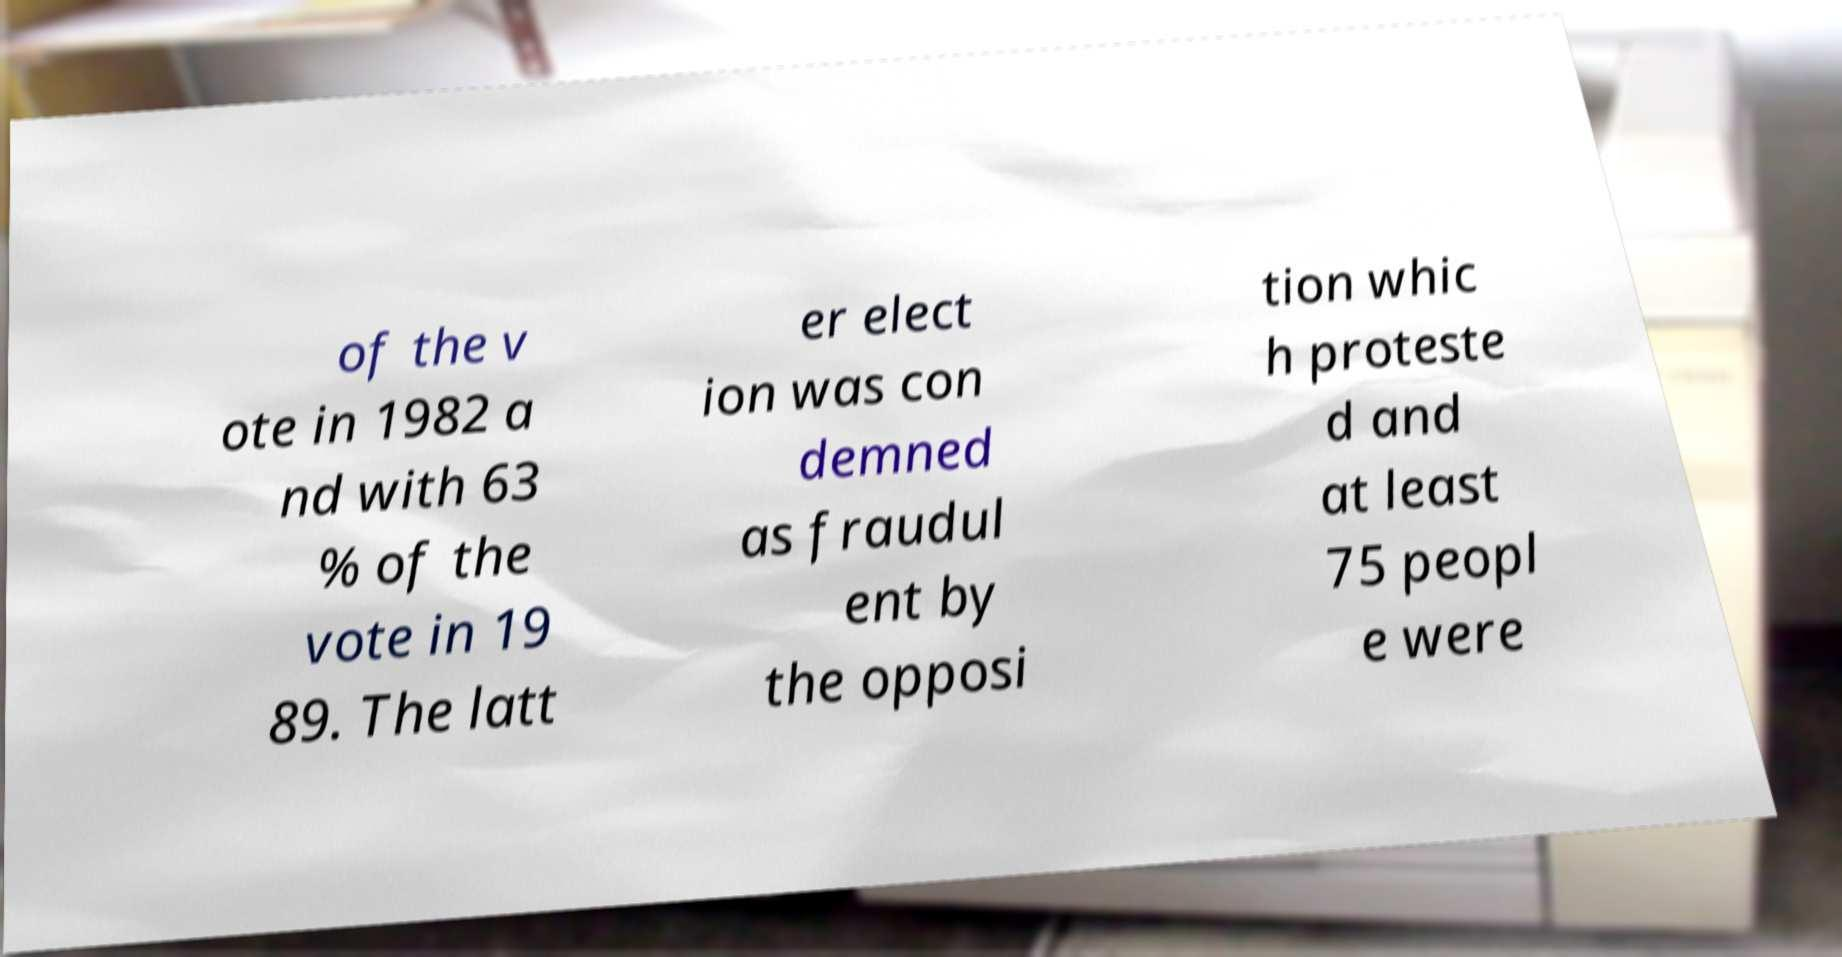There's text embedded in this image that I need extracted. Can you transcribe it verbatim? of the v ote in 1982 a nd with 63 % of the vote in 19 89. The latt er elect ion was con demned as fraudul ent by the opposi tion whic h proteste d and at least 75 peopl e were 